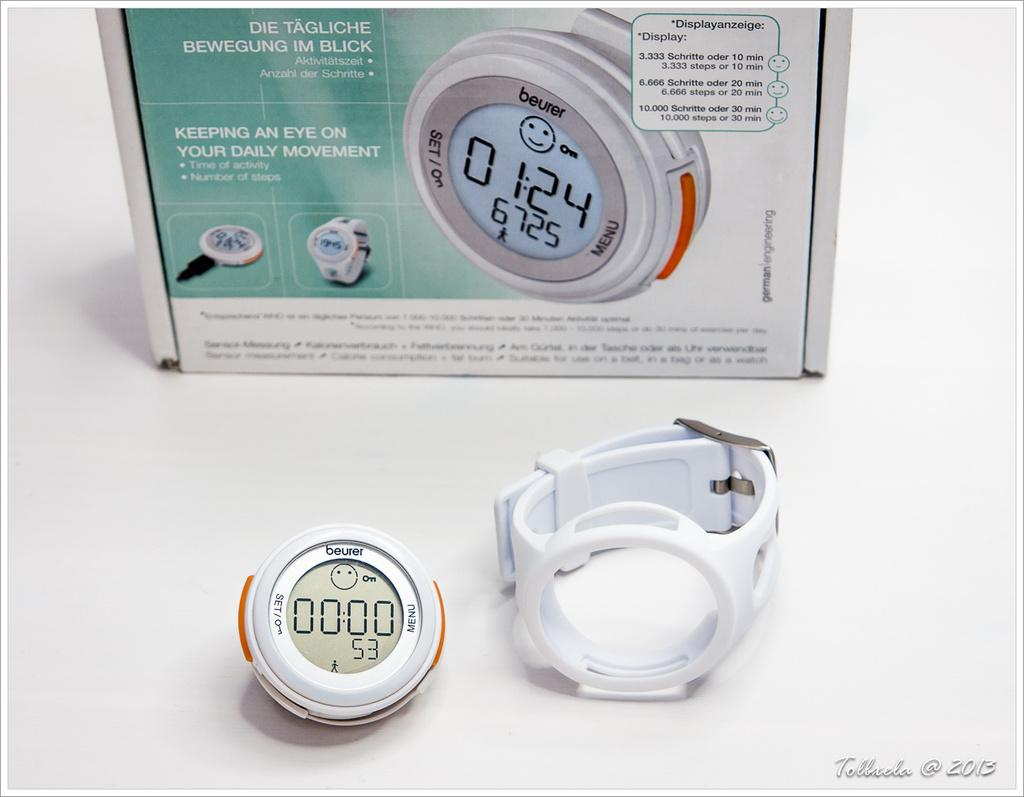<image>
Present a compact description of the photo's key features. A little round timer reads 00:00 on the display. 